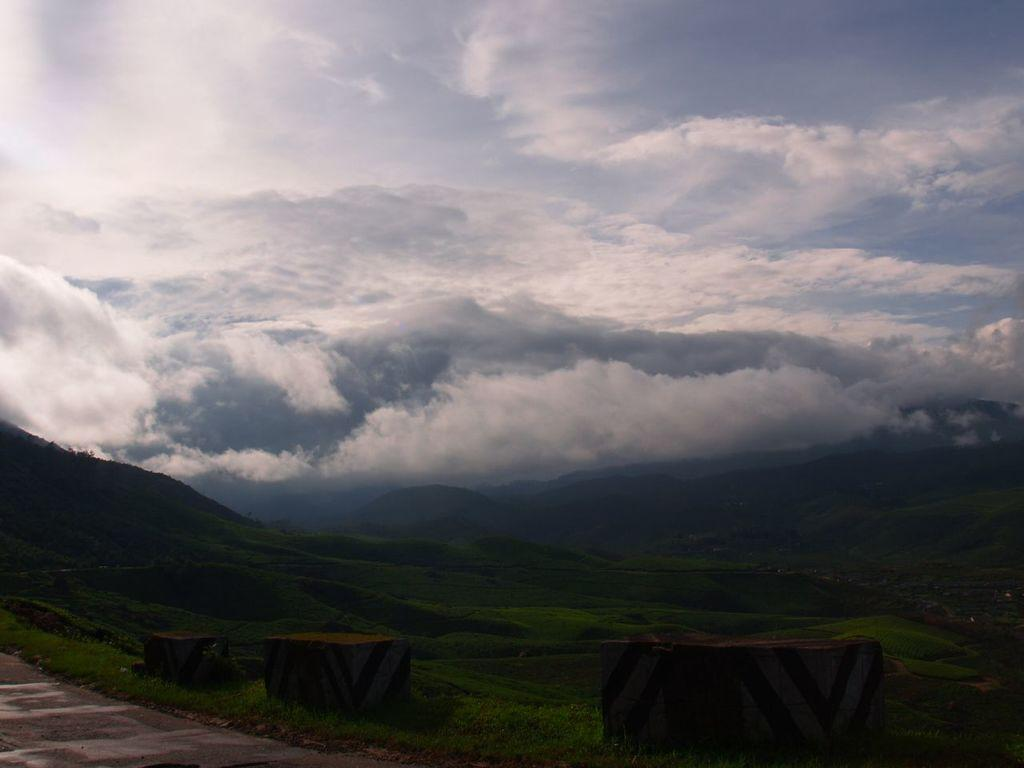What geographical feature is the main subject of the image? There is a mountain in the image. What is covering the mountain? The mountain is covered with trees. What can be seen above the mountain in the image? There is a sky visible in the image. What is present in the sky? Clouds are present in the sky. What type of sea creature can be seen swimming near the mountain in the image? There is no sea or sea creature present in the image; it features a mountain covered with trees and a sky with clouds. 